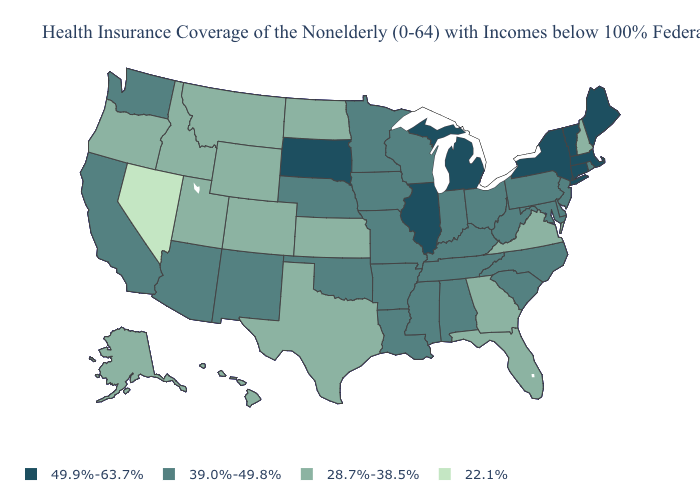Which states have the lowest value in the South?
Give a very brief answer. Florida, Georgia, Texas, Virginia. Does Connecticut have a lower value than North Dakota?
Keep it brief. No. Does Vermont have the lowest value in the USA?
Give a very brief answer. No. Is the legend a continuous bar?
Concise answer only. No. Does Tennessee have the same value as Arkansas?
Write a very short answer. Yes. What is the lowest value in states that border Colorado?
Concise answer only. 28.7%-38.5%. Does Vermont have the highest value in the USA?
Keep it brief. Yes. What is the value of Missouri?
Give a very brief answer. 39.0%-49.8%. Does Texas have a higher value than Nevada?
Quick response, please. Yes. Name the states that have a value in the range 28.7%-38.5%?
Give a very brief answer. Alaska, Colorado, Florida, Georgia, Hawaii, Idaho, Kansas, Montana, New Hampshire, North Dakota, Oregon, Texas, Utah, Virginia, Wyoming. Does North Dakota have the highest value in the MidWest?
Short answer required. No. Does Mississippi have the same value as Texas?
Give a very brief answer. No. Name the states that have a value in the range 28.7%-38.5%?
Be succinct. Alaska, Colorado, Florida, Georgia, Hawaii, Idaho, Kansas, Montana, New Hampshire, North Dakota, Oregon, Texas, Utah, Virginia, Wyoming. What is the value of Nevada?
Be succinct. 22.1%. Which states have the lowest value in the Northeast?
Concise answer only. New Hampshire. 